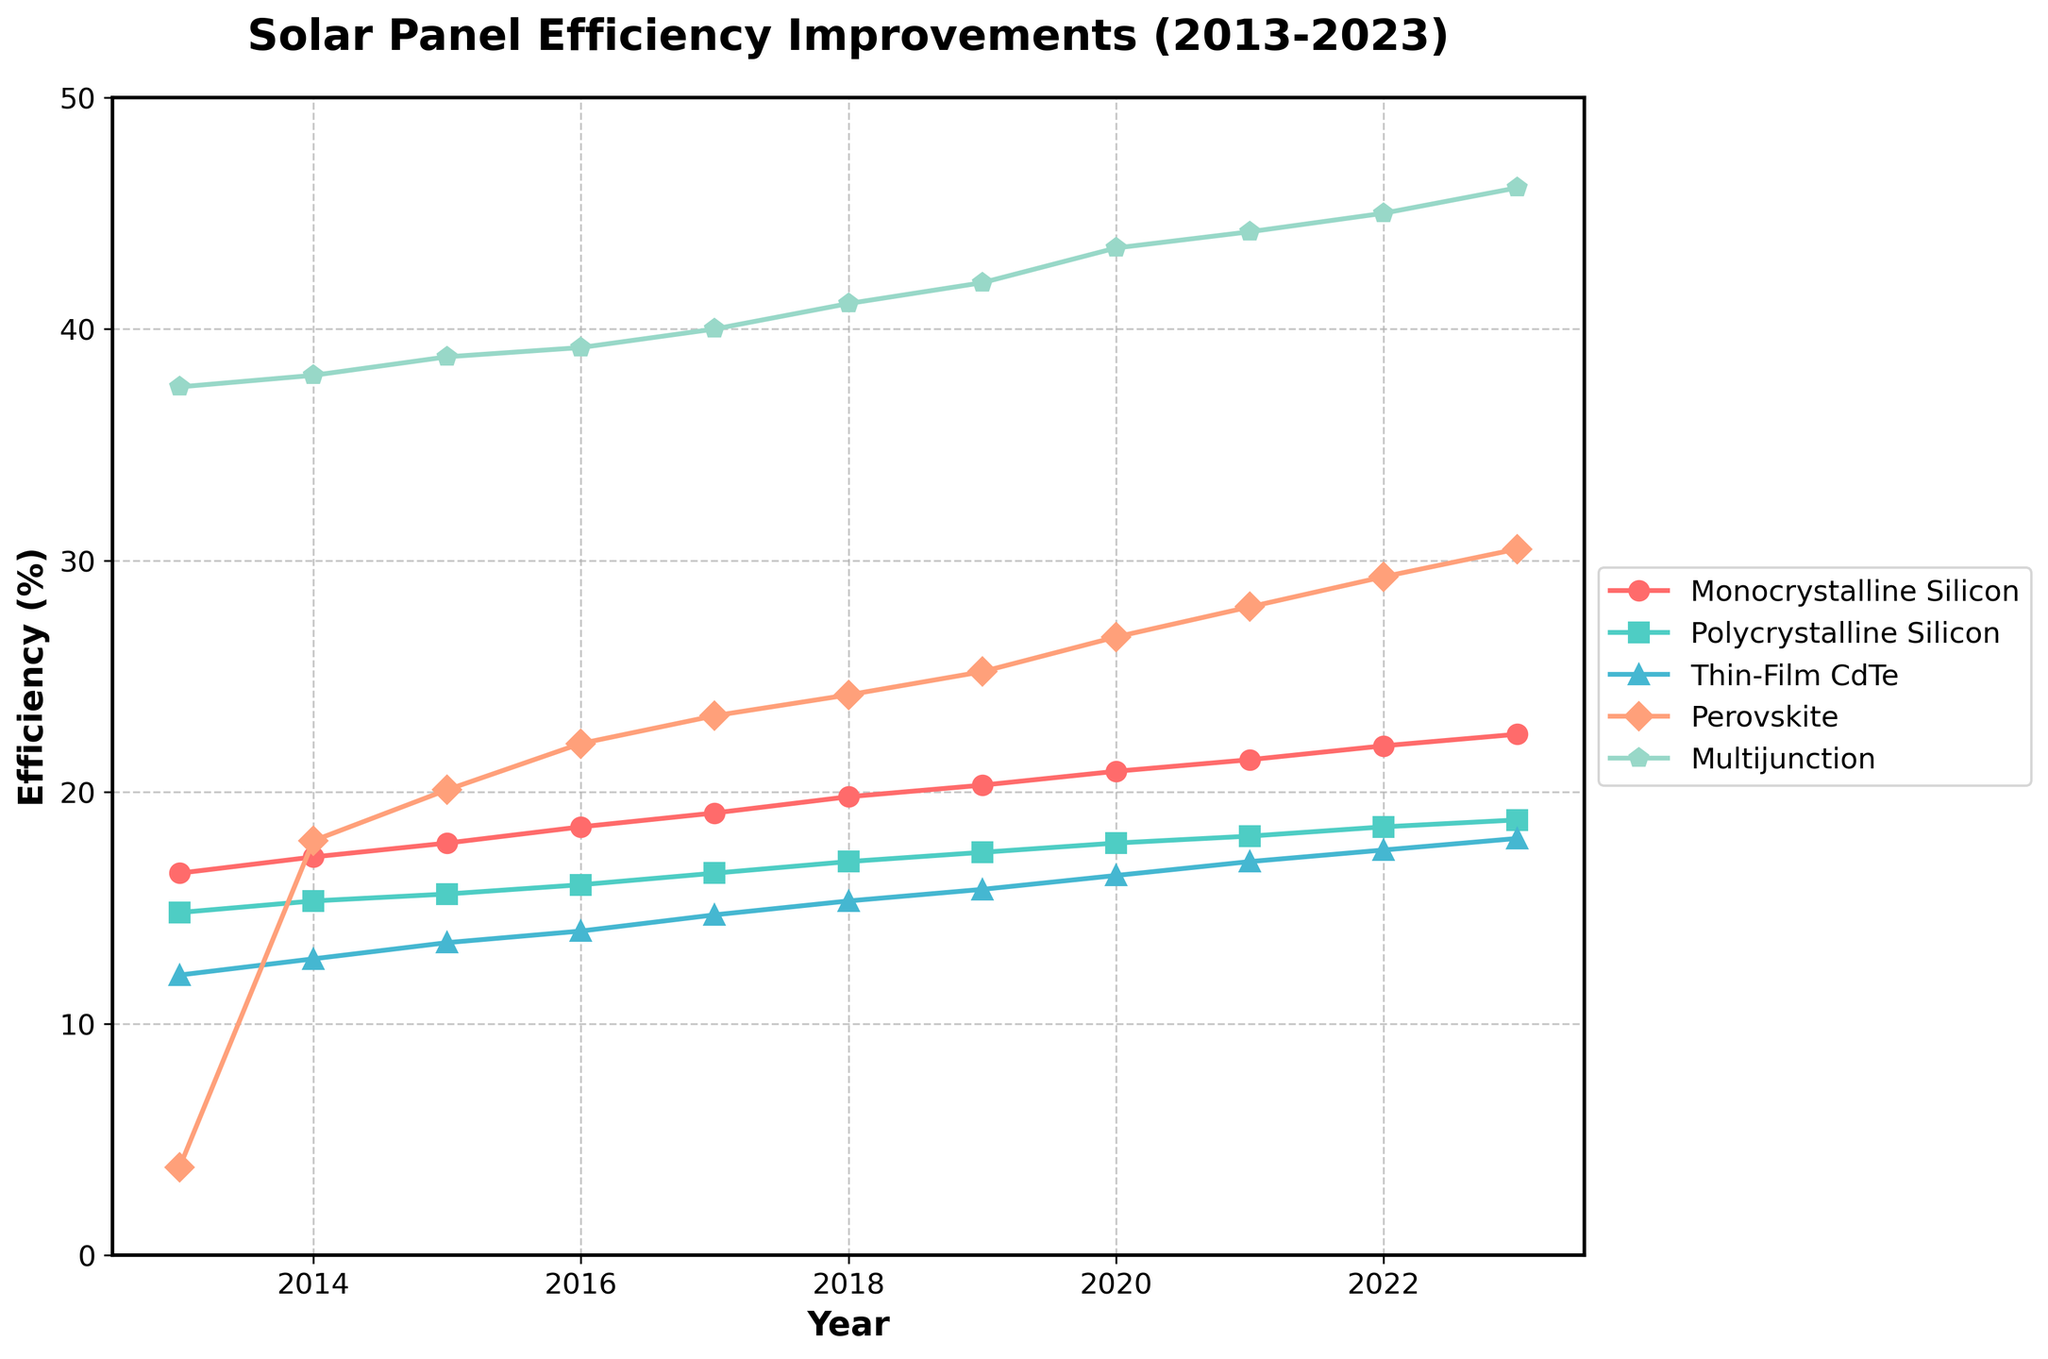What was the efficiency of Monocrystalline Silicon panels in 2020? The figure shows that in 2020, the efficiency of Monocrystalline Silicon panels was 20.9%.
Answer: 20.9% Which technology had the highest efficiency in 2016? By looking at the figure, Multijunction panels had the highest efficiency of 39.2% in 2016.
Answer: Multijunction How much did the efficiency of Polycrystalline Silicon panels increase from 2013 to 2023? Polycrystalline Silicon panels increased from 14.8% in 2013 to 18.8% in 2023. The increase is 18.8 - 14.8 = 4.
Answer: 4% In which year did Perovskite panels surpass 25% efficiency? Perovskite panels surpassed 25% efficiency in 2019.
Answer: 2019 How does the efficiency of Thin-Film CdTe in 2023 compare to its efficiency in 2013? Thin-Film CdTe's efficiency increased from 12.1% in 2013 to 18.0% in 2023. The increase is 18.0 - 12.1 = 5.9, indicating a significant improvement.
Answer: Increased by 5.9% What is the average efficiency of Multijunction panels over the decade? The efficiency values for Multijunction panels from 2013 to 2023 are: 37.5, 38.0, 38.8, 39.2, 40.0, 41.1, 42.0, 43.5, 44.2, 45.0, 46.1.
The sum of these values is 415.4. Dividing by 11 years, the average is 415.4 / 11 = 37.76.
Answer: 37.76% What is the combined efficiency of Monocrystalline and Polycrystalline Silicon panels in 2023? Monocrystalline Silicon panel efficiency in 2023 was 22.5%, and Polycrystalline Silicon panel efficiency was 18.8%. Adding them together, 22.5 + 18.8 = 41.3.
Answer: 41.3% In 2023, how much more efficient were Multijunction panels compared to Perovskite panels? The efficiency of Multijunction panels in 2023 was 46.1%, and the efficiency of Perovskite panels was 30.5%. The difference is 46.1 - 30.5 = 15.6.
Answer: 15.6% How did the efficiency of Thin-Film CdTe panels change between 2014 and 2018? The efficiency of Thin-Film CdTe panels was 12.8% in 2014 and 15.3% in 2018. The change is 15.3 - 12.8 = 2.5.
Answer: Increased by 2.5% 